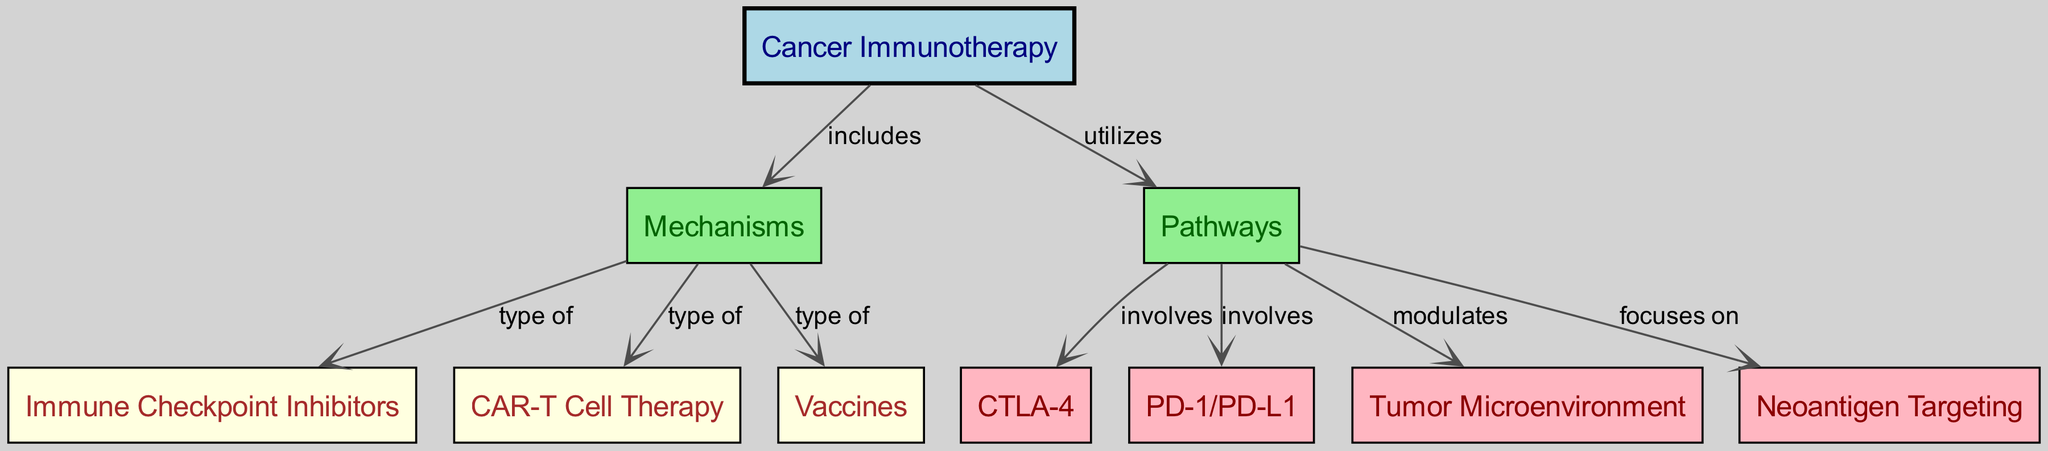What is the main subject of the diagram? The main subject of the diagram is presented by the first node labeled "Cancer Immunotherapy". It is the central theme from which all related concepts stem.
Answer: Cancer Immunotherapy How many types of mechanisms are listed in the diagram? The mechanisms associated with cancer immunotherapy are illustrated as three types: immune checkpoint inhibitors, CAR-T cell therapy, and vaccines. Counting these nodes gives a total of three.
Answer: 3 What pathway is associated with CTLA-4? The diagram indicates that CTLA-4 is involved in a specific pathway, linking it as a component under "involves". Therefore, CTLA-4 is associated with the mechanisms of cancer immunotherapy outlined in the pathway section.
Answer: CTLA-4 Which type of therapeutic approach is categorized under "type of" and is associated with the term "Vaccines"? The relationship specified in the diagram shows that "Vaccines" is categorized as a type of mechanism involved in cancer immunotherapy. It clearly indicates that vaccines play a role in the therapeutic approach.
Answer: Vaccines What does the pathway "Tumor Microenvironment" represent in the diagram? The "Tumor Microenvironment" is not only a pathway in the diagram but also indicates it modulates the interactions and impacts within cancer immunotherapy, showcasing its significance in the treatment context.
Answer: Tumor Microenvironment Which node focuses on neoantigen targeting? The diagram outlines that the node labeled "Neoantigen Targeting" is specifically mentioned under the pathway section that focuses on identifying specific antigens related to tumors, emphasizing its relevance in modern immunotherapies.
Answer: Neoantigen Targeting What type of edges connect the nodes "Cancer Immunotherapy" and "Mechanisms"? Based on the diagram, the edge connects these nodes with the label "includes", indicating that mechanisms are a subset or component of cancer immunotherapy.
Answer: includes How many total edges are there in the diagram? By reviewing the edges in the diagram, we can count a total of eight connections displaying relationships between different nodes related to cancer immunotherapy and its mechanisms.
Answer: 8 Which two pathways are identified in the diagram? The pathways identified in the diagram include "CTLA-4" and "PD-1/PD-L1", both of which are crucial in various immunotherapeutic strategies, indicating their importance in cancer treatment.
Answer: CTLA-4, PD-1/PD-L1 